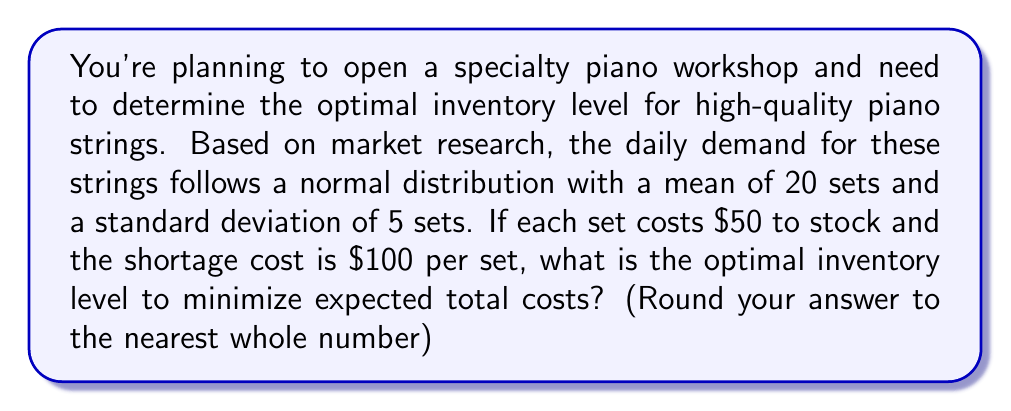Give your solution to this math problem. To determine the optimal inventory level, we'll use the concept of the critical fractile from the newsvendor model. The steps are as follows:

1) The critical fractile is given by:

   $$\text{Critical Fractile} = \frac{C_u}{C_u + C_o}$$

   Where $C_u$ is the underage (shortage) cost and $C_o$ is the overage cost.

2) In this case:
   $C_u = \$100$ (shortage cost per set)
   $C_o = \$50$ (cost to stock per set)

3) Plugging these values into the formula:

   $$\text{Critical Fractile} = \frac{100}{100 + 50} = \frac{2}{3} \approx 0.6667$$

4) This critical fractile corresponds to the z-score in the standard normal distribution. We can find this z-score using a standard normal table or a calculator. The z-score for 0.6667 is approximately 0.4307.

5) Now, we can use the z-score formula to find the optimal inventory level Q:

   $$Q = \mu + z\sigma$$

   Where $\mu$ is the mean demand and $\sigma$ is the standard deviation.

6) Plugging in our values:

   $$Q = 20 + (0.4307 * 5) = 20 + 2.1535 = 22.1535$$

7) Rounding to the nearest whole number (as we can't stock partial sets of strings):

   $$Q \approx 22$$

Therefore, the optimal inventory level is 22 sets of piano strings.
Answer: 22 sets 